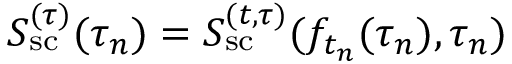Convert formula to latex. <formula><loc_0><loc_0><loc_500><loc_500>S _ { s c } ^ { ( \tau ) } ( \tau _ { n } ) = S _ { s c } ^ { ( t , \tau ) } ( f _ { t _ { n } } ( \tau _ { n } ) , \tau _ { n } )</formula> 